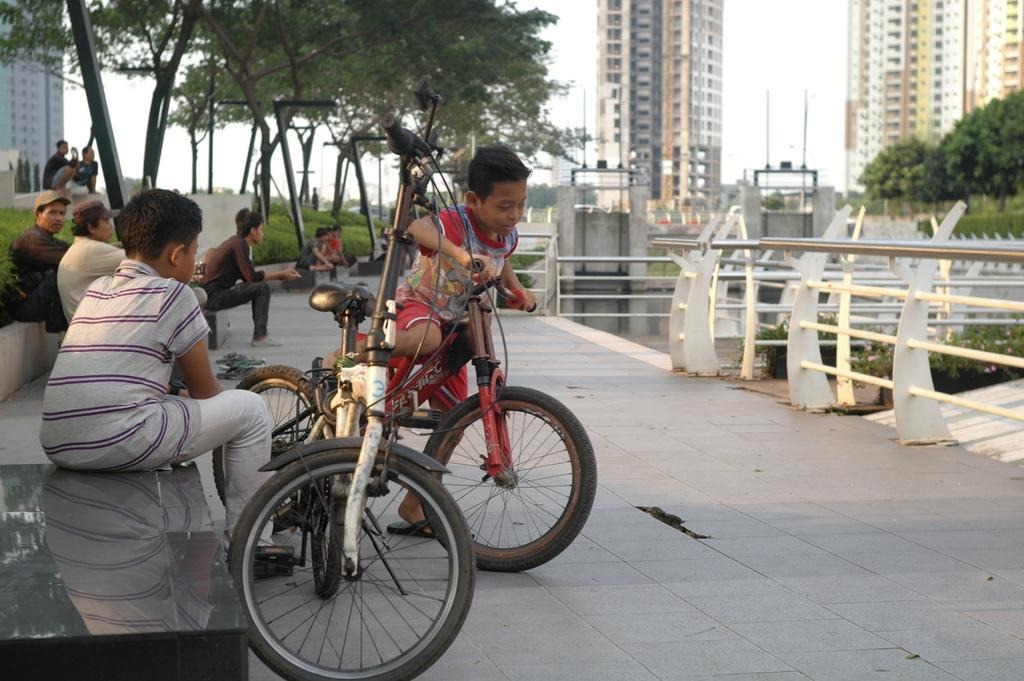What is the boy in the image doing? The boy is riding a bicycle in the image. What can be seen on the left side of the image? There are people sitting on the left side of the image. What is visible in the background of the image? There is a building, the sky, trees, and grass in the background of the image. How many geese are flying in the sky in the image? There are no geese visible in the sky in the image. What type of wound can be seen on the boy's knee in the image? There is no wound visible on the boy's knee in the image. 